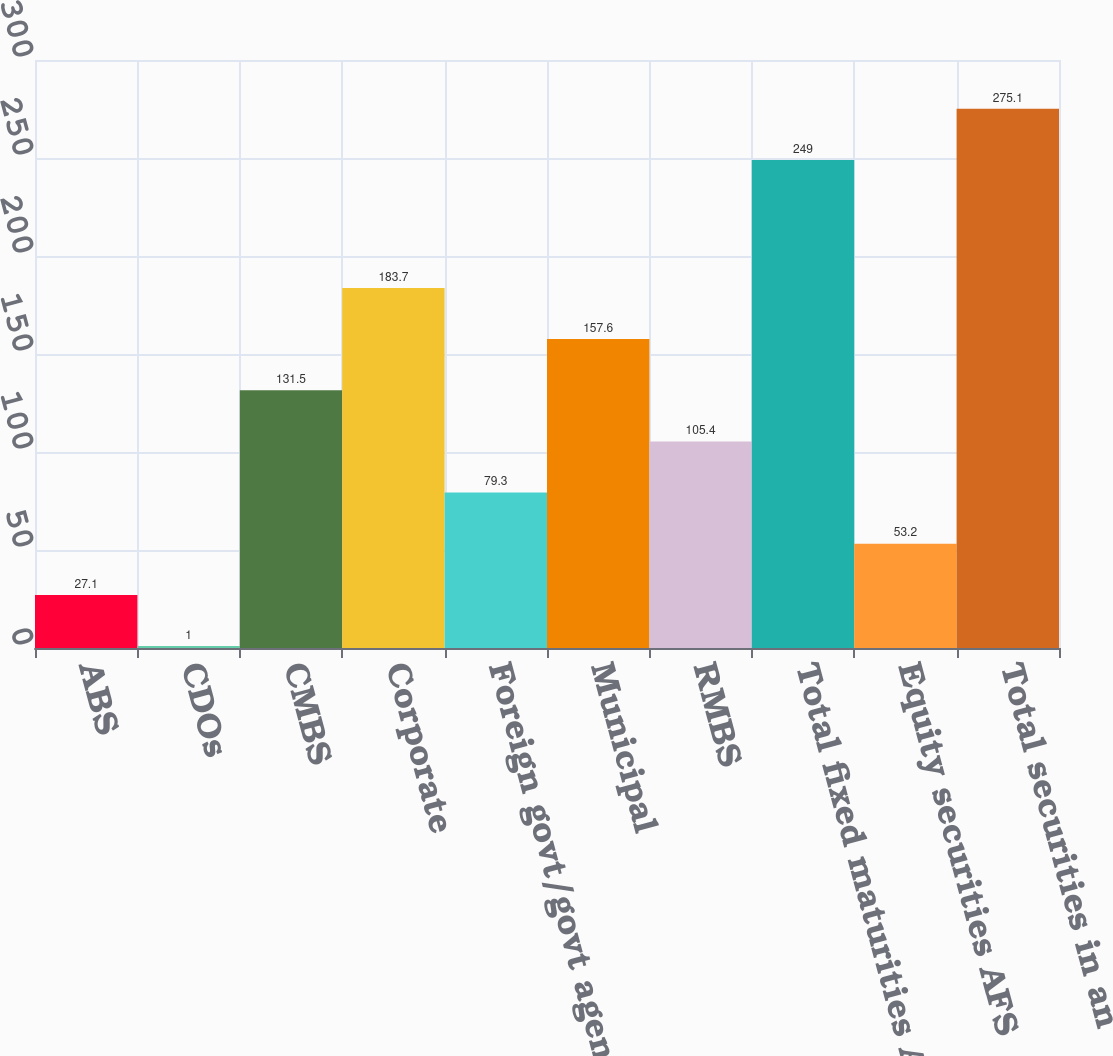Convert chart. <chart><loc_0><loc_0><loc_500><loc_500><bar_chart><fcel>ABS<fcel>CDOs<fcel>CMBS<fcel>Corporate<fcel>Foreign govt/govt agencies<fcel>Municipal<fcel>RMBS<fcel>Total fixed maturities AFS<fcel>Equity securities AFS<fcel>Total securities in an<nl><fcel>27.1<fcel>1<fcel>131.5<fcel>183.7<fcel>79.3<fcel>157.6<fcel>105.4<fcel>249<fcel>53.2<fcel>275.1<nl></chart> 